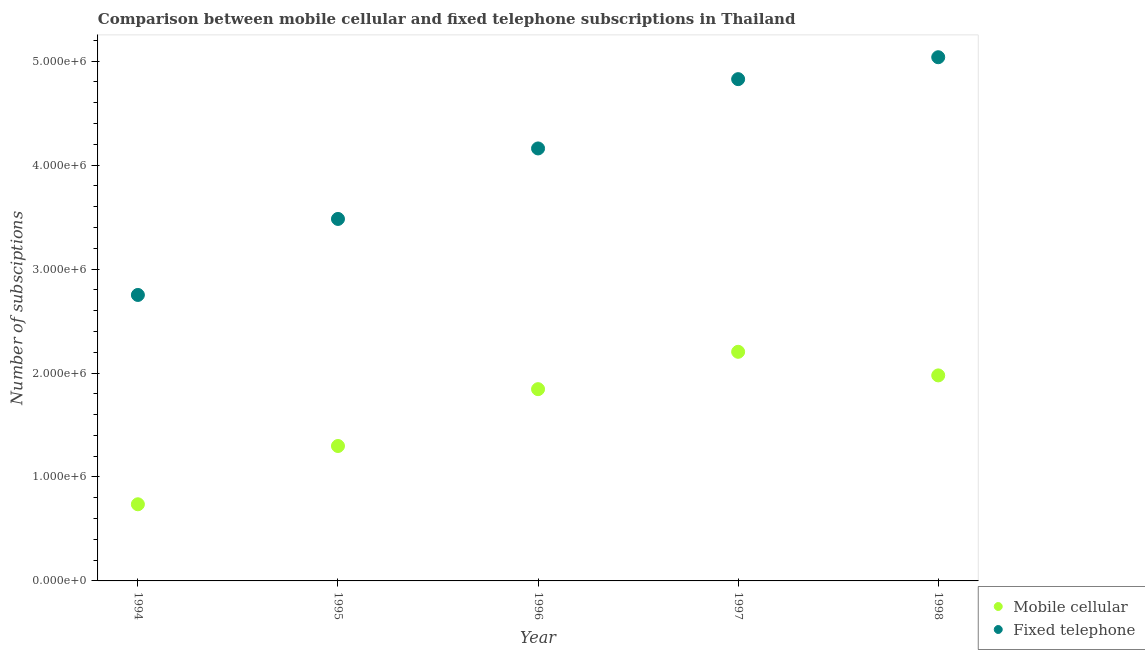Is the number of dotlines equal to the number of legend labels?
Ensure brevity in your answer.  Yes. What is the number of fixed telephone subscriptions in 1995?
Your response must be concise. 3.48e+06. Across all years, what is the maximum number of fixed telephone subscriptions?
Keep it short and to the point. 5.04e+06. Across all years, what is the minimum number of mobile cellular subscriptions?
Your answer should be very brief. 7.37e+05. What is the total number of mobile cellular subscriptions in the graph?
Your answer should be compact. 8.06e+06. What is the difference between the number of fixed telephone subscriptions in 1994 and that in 1998?
Offer a terse response. -2.29e+06. What is the difference between the number of mobile cellular subscriptions in 1994 and the number of fixed telephone subscriptions in 1995?
Your answer should be very brief. -2.74e+06. What is the average number of mobile cellular subscriptions per year?
Ensure brevity in your answer.  1.61e+06. In the year 1998, what is the difference between the number of fixed telephone subscriptions and number of mobile cellular subscriptions?
Keep it short and to the point. 3.06e+06. In how many years, is the number of mobile cellular subscriptions greater than 3600000?
Your answer should be compact. 0. What is the ratio of the number of mobile cellular subscriptions in 1997 to that in 1998?
Make the answer very short. 1.11. Is the number of mobile cellular subscriptions in 1994 less than that in 1997?
Provide a succinct answer. Yes. Is the difference between the number of mobile cellular subscriptions in 1994 and 1996 greater than the difference between the number of fixed telephone subscriptions in 1994 and 1996?
Your answer should be very brief. Yes. What is the difference between the highest and the second highest number of mobile cellular subscriptions?
Provide a succinct answer. 2.27e+05. What is the difference between the highest and the lowest number of mobile cellular subscriptions?
Your answer should be very brief. 1.47e+06. In how many years, is the number of mobile cellular subscriptions greater than the average number of mobile cellular subscriptions taken over all years?
Ensure brevity in your answer.  3. Is the sum of the number of fixed telephone subscriptions in 1994 and 1998 greater than the maximum number of mobile cellular subscriptions across all years?
Keep it short and to the point. Yes. Does the number of fixed telephone subscriptions monotonically increase over the years?
Keep it short and to the point. Yes. Does the graph contain any zero values?
Give a very brief answer. No. Does the graph contain grids?
Your response must be concise. No. Where does the legend appear in the graph?
Offer a terse response. Bottom right. What is the title of the graph?
Provide a short and direct response. Comparison between mobile cellular and fixed telephone subscriptions in Thailand. Does "Researchers" appear as one of the legend labels in the graph?
Your response must be concise. No. What is the label or title of the Y-axis?
Provide a succinct answer. Number of subsciptions. What is the Number of subsciptions of Mobile cellular in 1994?
Ensure brevity in your answer.  7.37e+05. What is the Number of subsciptions in Fixed telephone in 1994?
Offer a terse response. 2.75e+06. What is the Number of subsciptions in Mobile cellular in 1995?
Offer a very short reply. 1.30e+06. What is the Number of subsciptions of Fixed telephone in 1995?
Your response must be concise. 3.48e+06. What is the Number of subsciptions of Mobile cellular in 1996?
Give a very brief answer. 1.84e+06. What is the Number of subsciptions in Fixed telephone in 1996?
Provide a succinct answer. 4.16e+06. What is the Number of subsciptions of Mobile cellular in 1997?
Provide a short and direct response. 2.20e+06. What is the Number of subsciptions of Fixed telephone in 1997?
Provide a succinct answer. 4.83e+06. What is the Number of subsciptions in Mobile cellular in 1998?
Provide a succinct answer. 1.98e+06. What is the Number of subsciptions in Fixed telephone in 1998?
Ensure brevity in your answer.  5.04e+06. Across all years, what is the maximum Number of subsciptions of Mobile cellular?
Offer a very short reply. 2.20e+06. Across all years, what is the maximum Number of subsciptions in Fixed telephone?
Your answer should be very brief. 5.04e+06. Across all years, what is the minimum Number of subsciptions of Mobile cellular?
Provide a succinct answer. 7.37e+05. Across all years, what is the minimum Number of subsciptions of Fixed telephone?
Keep it short and to the point. 2.75e+06. What is the total Number of subsciptions of Mobile cellular in the graph?
Offer a very short reply. 8.06e+06. What is the total Number of subsciptions of Fixed telephone in the graph?
Offer a very short reply. 2.03e+07. What is the difference between the Number of subsciptions of Mobile cellular in 1994 and that in 1995?
Make the answer very short. -5.61e+05. What is the difference between the Number of subsciptions in Fixed telephone in 1994 and that in 1995?
Provide a succinct answer. -7.31e+05. What is the difference between the Number of subsciptions in Mobile cellular in 1994 and that in 1996?
Ensure brevity in your answer.  -1.11e+06. What is the difference between the Number of subsciptions of Fixed telephone in 1994 and that in 1996?
Ensure brevity in your answer.  -1.41e+06. What is the difference between the Number of subsciptions in Mobile cellular in 1994 and that in 1997?
Offer a terse response. -1.47e+06. What is the difference between the Number of subsciptions in Fixed telephone in 1994 and that in 1997?
Give a very brief answer. -2.08e+06. What is the difference between the Number of subsciptions of Mobile cellular in 1994 and that in 1998?
Provide a short and direct response. -1.24e+06. What is the difference between the Number of subsciptions in Fixed telephone in 1994 and that in 1998?
Your answer should be very brief. -2.29e+06. What is the difference between the Number of subsciptions in Mobile cellular in 1995 and that in 1996?
Provide a short and direct response. -5.47e+05. What is the difference between the Number of subsciptions in Fixed telephone in 1995 and that in 1996?
Provide a succinct answer. -6.78e+05. What is the difference between the Number of subsciptions in Mobile cellular in 1995 and that in 1997?
Offer a very short reply. -9.06e+05. What is the difference between the Number of subsciptions in Fixed telephone in 1995 and that in 1997?
Offer a terse response. -1.34e+06. What is the difference between the Number of subsciptions in Mobile cellular in 1995 and that in 1998?
Provide a succinct answer. -6.79e+05. What is the difference between the Number of subsciptions of Fixed telephone in 1995 and that in 1998?
Ensure brevity in your answer.  -1.56e+06. What is the difference between the Number of subsciptions of Mobile cellular in 1996 and that in 1997?
Offer a very short reply. -3.59e+05. What is the difference between the Number of subsciptions in Fixed telephone in 1996 and that in 1997?
Provide a short and direct response. -6.67e+05. What is the difference between the Number of subsciptions of Mobile cellular in 1996 and that in 1998?
Provide a succinct answer. -1.32e+05. What is the difference between the Number of subsciptions of Fixed telephone in 1996 and that in 1998?
Ensure brevity in your answer.  -8.77e+05. What is the difference between the Number of subsciptions in Mobile cellular in 1997 and that in 1998?
Keep it short and to the point. 2.27e+05. What is the difference between the Number of subsciptions of Fixed telephone in 1997 and that in 1998?
Make the answer very short. -2.11e+05. What is the difference between the Number of subsciptions in Mobile cellular in 1994 and the Number of subsciptions in Fixed telephone in 1995?
Provide a short and direct response. -2.74e+06. What is the difference between the Number of subsciptions in Mobile cellular in 1994 and the Number of subsciptions in Fixed telephone in 1996?
Make the answer very short. -3.42e+06. What is the difference between the Number of subsciptions of Mobile cellular in 1994 and the Number of subsciptions of Fixed telephone in 1997?
Your response must be concise. -4.09e+06. What is the difference between the Number of subsciptions in Mobile cellular in 1994 and the Number of subsciptions in Fixed telephone in 1998?
Offer a terse response. -4.30e+06. What is the difference between the Number of subsciptions in Mobile cellular in 1995 and the Number of subsciptions in Fixed telephone in 1996?
Your answer should be compact. -2.86e+06. What is the difference between the Number of subsciptions in Mobile cellular in 1995 and the Number of subsciptions in Fixed telephone in 1997?
Offer a very short reply. -3.53e+06. What is the difference between the Number of subsciptions in Mobile cellular in 1995 and the Number of subsciptions in Fixed telephone in 1998?
Your response must be concise. -3.74e+06. What is the difference between the Number of subsciptions in Mobile cellular in 1996 and the Number of subsciptions in Fixed telephone in 1997?
Your answer should be very brief. -2.98e+06. What is the difference between the Number of subsciptions of Mobile cellular in 1996 and the Number of subsciptions of Fixed telephone in 1998?
Make the answer very short. -3.19e+06. What is the difference between the Number of subsciptions of Mobile cellular in 1997 and the Number of subsciptions of Fixed telephone in 1998?
Your answer should be very brief. -2.83e+06. What is the average Number of subsciptions in Mobile cellular per year?
Your response must be concise. 1.61e+06. What is the average Number of subsciptions in Fixed telephone per year?
Your answer should be very brief. 4.05e+06. In the year 1994, what is the difference between the Number of subsciptions in Mobile cellular and Number of subsciptions in Fixed telephone?
Your answer should be compact. -2.01e+06. In the year 1995, what is the difference between the Number of subsciptions of Mobile cellular and Number of subsciptions of Fixed telephone?
Offer a terse response. -2.18e+06. In the year 1996, what is the difference between the Number of subsciptions in Mobile cellular and Number of subsciptions in Fixed telephone?
Make the answer very short. -2.32e+06. In the year 1997, what is the difference between the Number of subsciptions in Mobile cellular and Number of subsciptions in Fixed telephone?
Ensure brevity in your answer.  -2.62e+06. In the year 1998, what is the difference between the Number of subsciptions in Mobile cellular and Number of subsciptions in Fixed telephone?
Offer a very short reply. -3.06e+06. What is the ratio of the Number of subsciptions in Mobile cellular in 1994 to that in 1995?
Your answer should be very brief. 0.57. What is the ratio of the Number of subsciptions in Fixed telephone in 1994 to that in 1995?
Make the answer very short. 0.79. What is the ratio of the Number of subsciptions in Mobile cellular in 1994 to that in 1996?
Your answer should be compact. 0.4. What is the ratio of the Number of subsciptions of Fixed telephone in 1994 to that in 1996?
Offer a terse response. 0.66. What is the ratio of the Number of subsciptions of Mobile cellular in 1994 to that in 1997?
Provide a succinct answer. 0.33. What is the ratio of the Number of subsciptions of Fixed telephone in 1994 to that in 1997?
Your answer should be very brief. 0.57. What is the ratio of the Number of subsciptions in Mobile cellular in 1994 to that in 1998?
Provide a short and direct response. 0.37. What is the ratio of the Number of subsciptions of Fixed telephone in 1994 to that in 1998?
Your answer should be very brief. 0.55. What is the ratio of the Number of subsciptions of Mobile cellular in 1995 to that in 1996?
Offer a terse response. 0.7. What is the ratio of the Number of subsciptions of Fixed telephone in 1995 to that in 1996?
Offer a terse response. 0.84. What is the ratio of the Number of subsciptions in Mobile cellular in 1995 to that in 1997?
Provide a short and direct response. 0.59. What is the ratio of the Number of subsciptions in Fixed telephone in 1995 to that in 1997?
Provide a succinct answer. 0.72. What is the ratio of the Number of subsciptions in Mobile cellular in 1995 to that in 1998?
Provide a short and direct response. 0.66. What is the ratio of the Number of subsciptions in Fixed telephone in 1995 to that in 1998?
Keep it short and to the point. 0.69. What is the ratio of the Number of subsciptions in Mobile cellular in 1996 to that in 1997?
Keep it short and to the point. 0.84. What is the ratio of the Number of subsciptions of Fixed telephone in 1996 to that in 1997?
Keep it short and to the point. 0.86. What is the ratio of the Number of subsciptions of Mobile cellular in 1996 to that in 1998?
Offer a very short reply. 0.93. What is the ratio of the Number of subsciptions of Fixed telephone in 1996 to that in 1998?
Ensure brevity in your answer.  0.83. What is the ratio of the Number of subsciptions of Mobile cellular in 1997 to that in 1998?
Give a very brief answer. 1.11. What is the ratio of the Number of subsciptions of Fixed telephone in 1997 to that in 1998?
Offer a terse response. 0.96. What is the difference between the highest and the second highest Number of subsciptions in Mobile cellular?
Make the answer very short. 2.27e+05. What is the difference between the highest and the second highest Number of subsciptions of Fixed telephone?
Make the answer very short. 2.11e+05. What is the difference between the highest and the lowest Number of subsciptions of Mobile cellular?
Provide a short and direct response. 1.47e+06. What is the difference between the highest and the lowest Number of subsciptions in Fixed telephone?
Offer a terse response. 2.29e+06. 